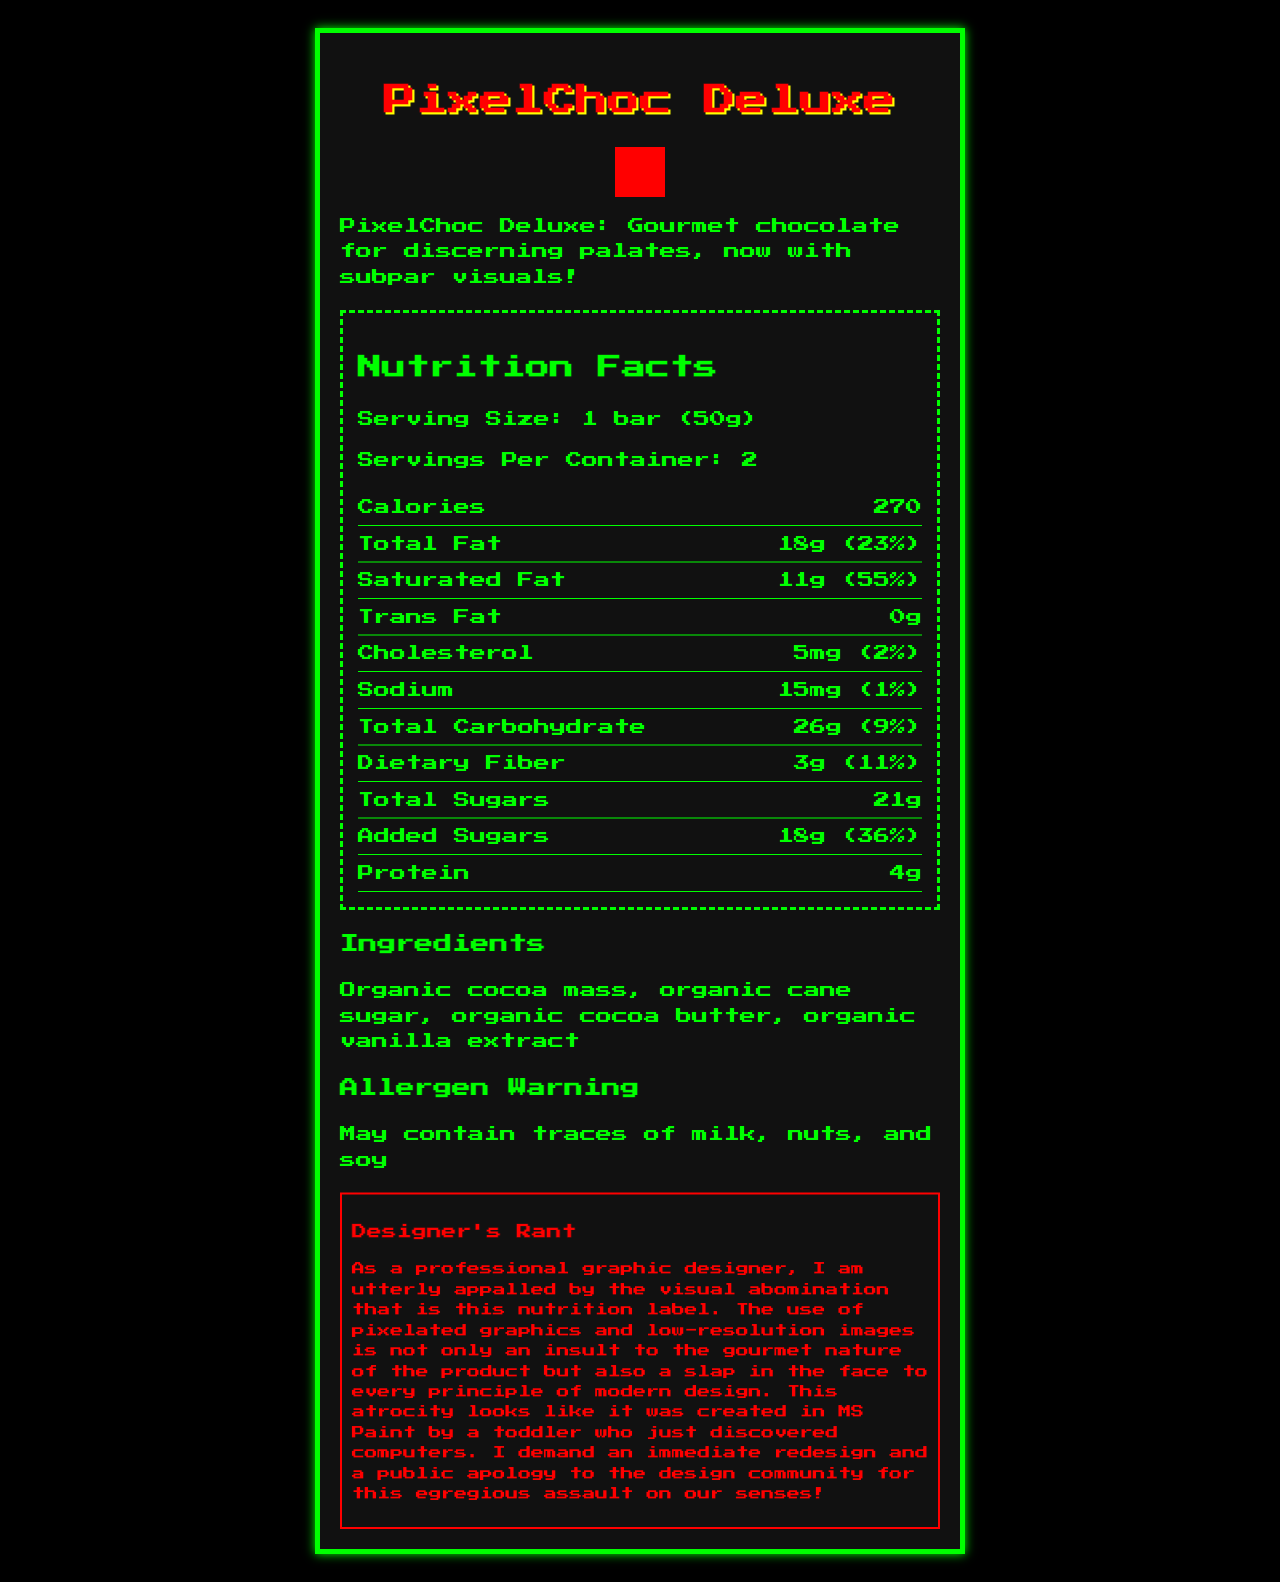what is the serving size for PixelChoc Deluxe? The serving size is explicitly mentioned in the Nutrition Facts section under "Serving Size."
Answer: 1 bar (50g) how many servings per container are there? The document states "Servings Per Container: 2" in the Nutrition Facts section.
Answer: 2 how many calories are there per serving of PixelChoc Deluxe? This information is listed under the nutrition facts, next to the label "Calories."
Answer: 270 what is the daily value percentage of saturated fat per serving? The daily value percentage for Saturated Fat is provided in the Nutrition Facts section as "11g (55%)."
Answer: 55% what allergen warnings are provided on the label? This information is found under the "Allergen Warning" section of the document.
Answer: May contain traces of milk, nuts, and soy which nutrient has the highest daily value percentage per serving? A. Total Fat B. Saturated Fat C. Sodium D. Dietary Fiber According to the nutrition facts, Saturated Fat has the highest daily value percentage (55%).
Answer: B how much potassium is there per serving? A. 100mg B. 150mg C. 200mg D. 250mg The amount of potassium per serving is listed as "200mg" in the Nutrition Facts section.
Answer: C does the document have any dietary fiber? The dietary fiber amount is 3g, with an 11% daily value listed in the Nutrition Facts section.
Answer: Yes summarize the main idea of the document. The document presents the nutritional content of a chocolate bar, along with its key characteristics and the designer's strong critique of its graphic design quality.
Answer: A Nutrition Facts Label for PixelChoc Deluxe, which consists of detailed nutritional information, ingredients, and allergen warnings, wrapped in a visibly poor graphic design. how many grams of added sugars does the PixelChoc Deluxe contain? The amount of added sugars is explicitly mentioned as "18g" in the Nutrition Facts section.
Answer: 18g what is the serving size of calcium provided per serving? The Nutrition Facts section specifies the amount of calcium as "50mg."
Answer: 50mg what is the product's brand statement? The brand statement is clearly mentioned under the product information.
Answer: PixelChoc Deluxe: Gourmet chocolate for discerning palates, now with subpar visuals! how are the images described in the document? Various complaints in the document highlight the pixelated graphics and low-resolution images.
Answer: Pixelated and low-resolution does the document include information about Vitamin C? The provided Nutrition Facts do not list any information about Vitamin C.
Answer: No what is the designer complaint regarding the typographic logo of the product? This specific complaint is mentioned in the designer complaints section.
Answer: The product logo is a disgrace to the art of typography what is the rate of iron's daily value given per serving? Iron's daily value is listed as "2.5mg (15%)" in the Nutrition Facts section.
Answer: 15% what visual elements are criticized as looking like other objects in the document? The low-resolution images section lists these specific criticisms about the visual elements.
Answer: A blurry photo of cocoa pods that could be mistaken for potatoes; a grainy image of a chocolatier that looks more like bigfoot; a pixelated close-up of chocolate texture that resembles brown static can you determine the manufacturing location of PixelChoc Deluxe from the document? The document does not provide details on the manufacturing location.
Answer: Not enough information 